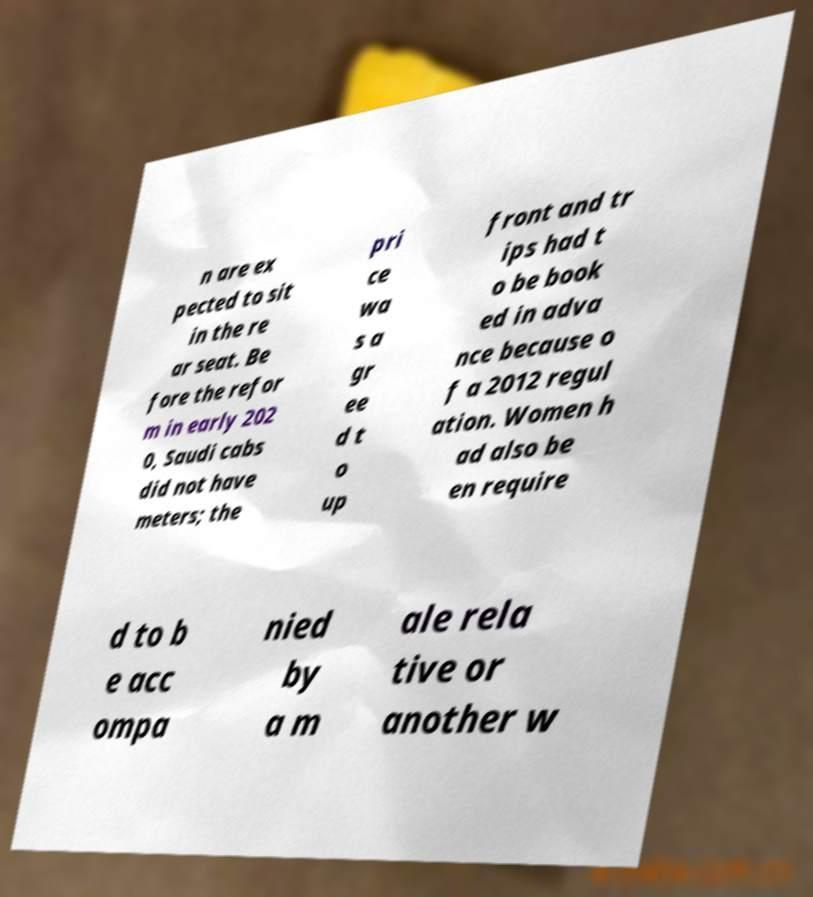What messages or text are displayed in this image? I need them in a readable, typed format. n are ex pected to sit in the re ar seat. Be fore the refor m in early 202 0, Saudi cabs did not have meters; the pri ce wa s a gr ee d t o up front and tr ips had t o be book ed in adva nce because o f a 2012 regul ation. Women h ad also be en require d to b e acc ompa nied by a m ale rela tive or another w 